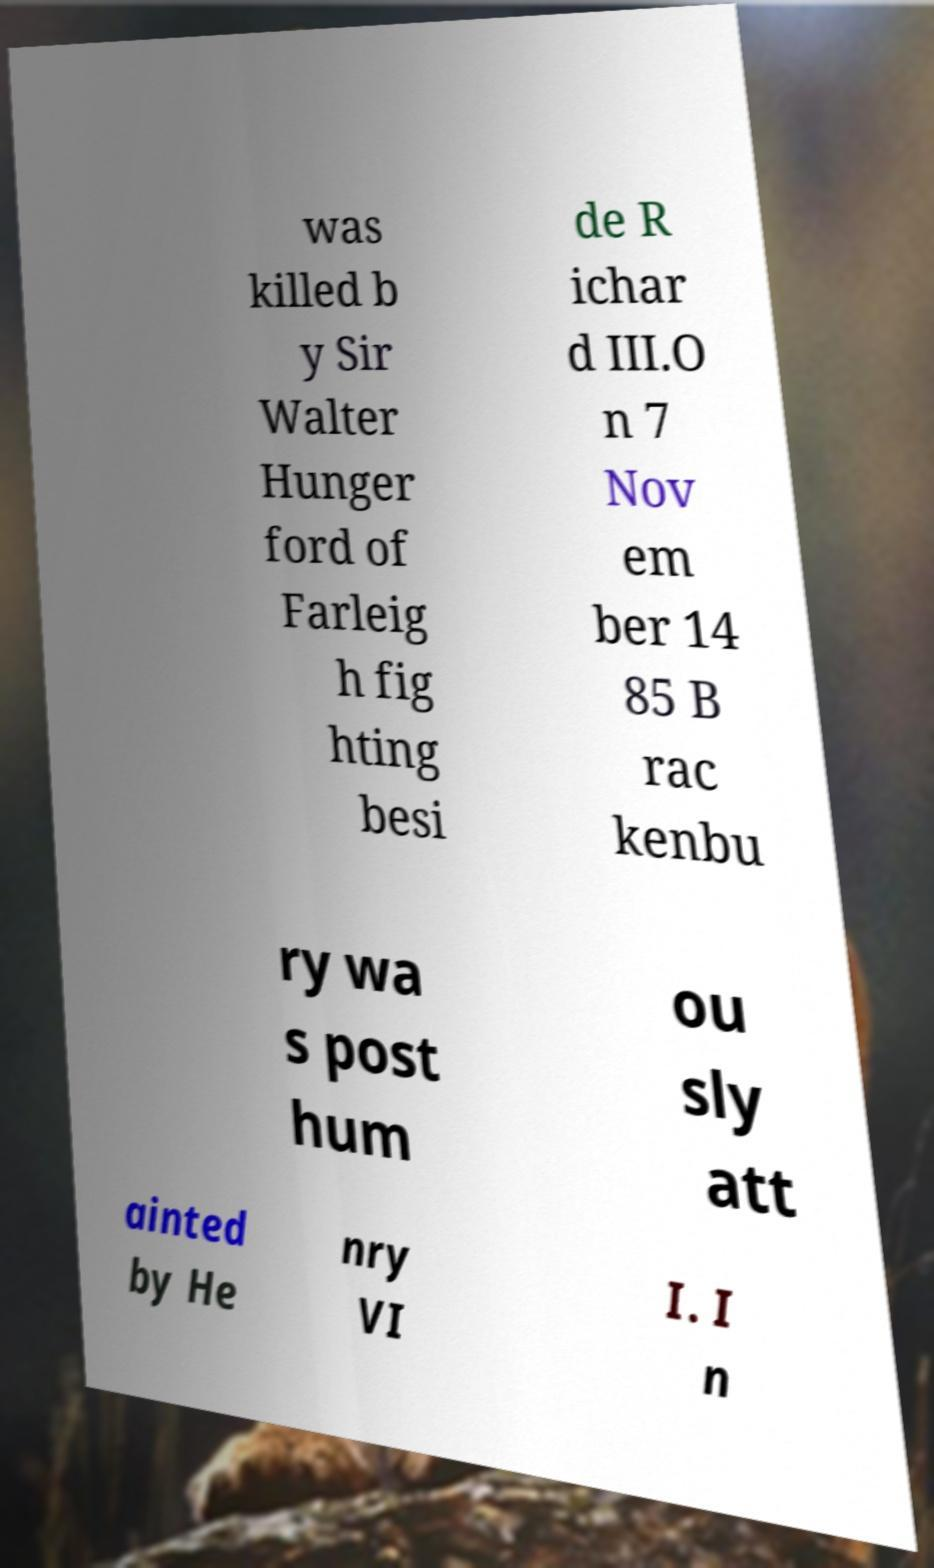Please identify and transcribe the text found in this image. was killed b y Sir Walter Hunger ford of Farleig h fig hting besi de R ichar d III.O n 7 Nov em ber 14 85 B rac kenbu ry wa s post hum ou sly att ainted by He nry VI I. I n 